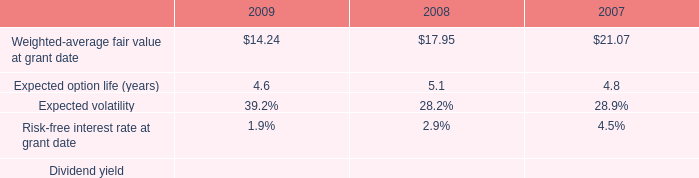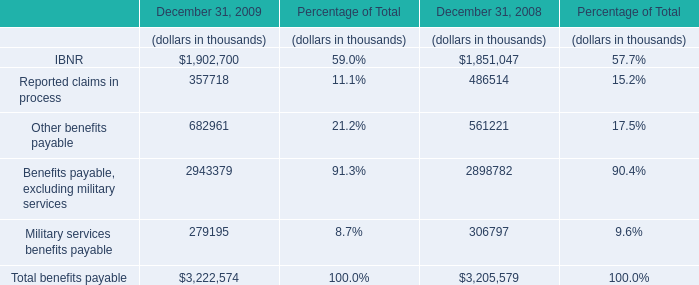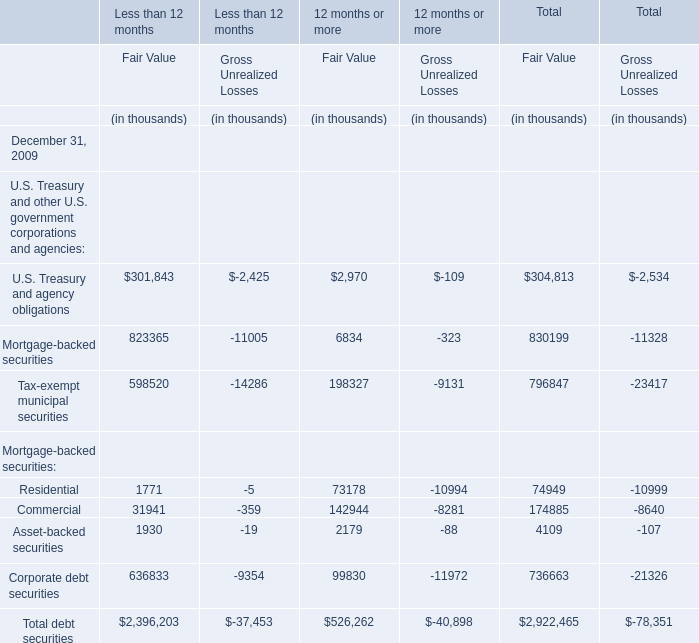What's the 20 % of total elements for Fair Value of Less than 12 months in 2009? (in thousand) 
Computations: (2396203 * 0.2)
Answer: 479240.6. 